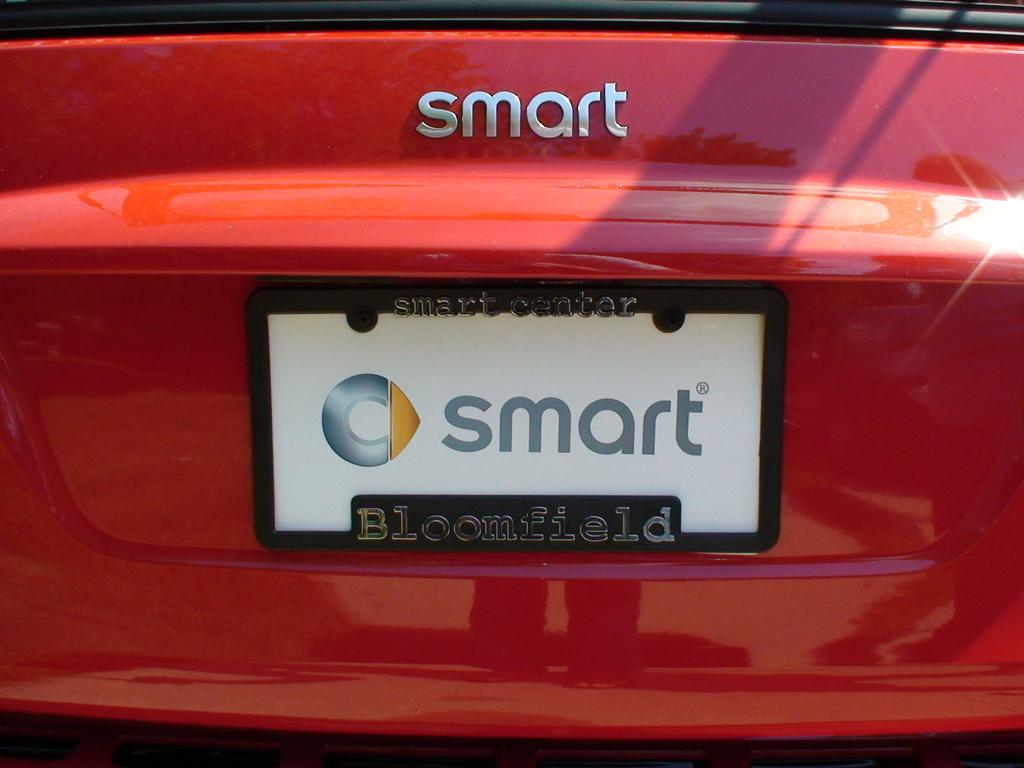<image>
Summarize the visual content of the image. Red car with a license plate which says Smart onit. 